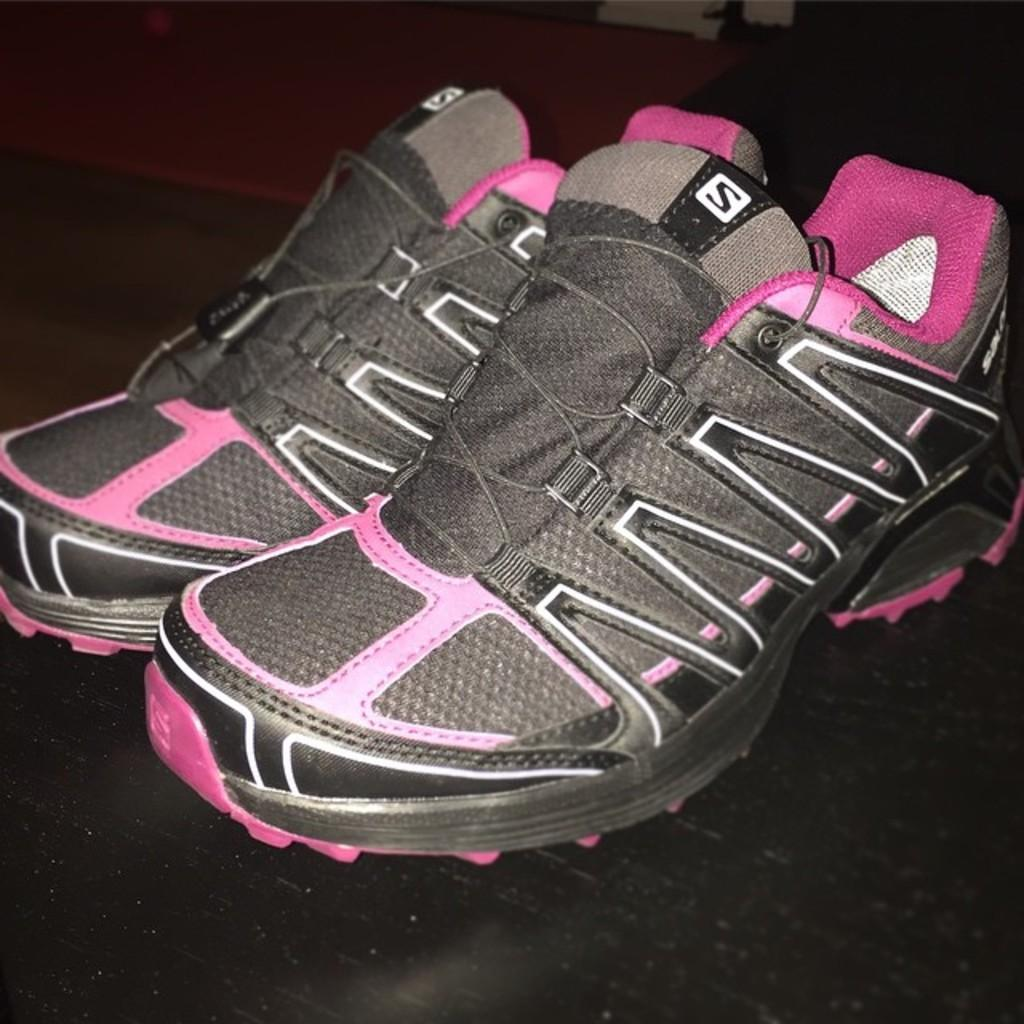What type of object is present in the image? There is a pair of shoes in the image. Where are the shoes located? The shoes are kept on a surface. What type of glove is being used by the manager in the image? There is no glove or manager present in the image; it only features a pair of shoes on a surface. 